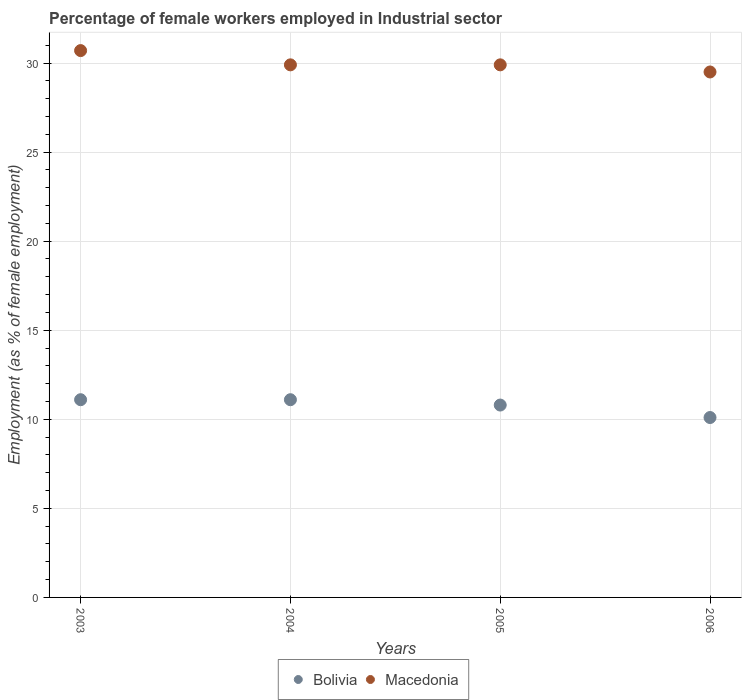What is the percentage of females employed in Industrial sector in Bolivia in 2005?
Provide a short and direct response. 10.8. Across all years, what is the maximum percentage of females employed in Industrial sector in Bolivia?
Your answer should be compact. 11.1. Across all years, what is the minimum percentage of females employed in Industrial sector in Macedonia?
Offer a terse response. 29.5. In which year was the percentage of females employed in Industrial sector in Macedonia minimum?
Offer a very short reply. 2006. What is the total percentage of females employed in Industrial sector in Bolivia in the graph?
Your response must be concise. 43.1. What is the difference between the percentage of females employed in Industrial sector in Bolivia in 2004 and that in 2005?
Give a very brief answer. 0.3. What is the difference between the percentage of females employed in Industrial sector in Macedonia in 2006 and the percentage of females employed in Industrial sector in Bolivia in 2004?
Provide a succinct answer. 18.4. What is the average percentage of females employed in Industrial sector in Macedonia per year?
Ensure brevity in your answer.  30. In the year 2004, what is the difference between the percentage of females employed in Industrial sector in Macedonia and percentage of females employed in Industrial sector in Bolivia?
Keep it short and to the point. 18.8. What is the ratio of the percentage of females employed in Industrial sector in Macedonia in 2005 to that in 2006?
Make the answer very short. 1.01. Is the percentage of females employed in Industrial sector in Macedonia in 2004 less than that in 2006?
Your answer should be very brief. No. What is the difference between the highest and the second highest percentage of females employed in Industrial sector in Macedonia?
Provide a succinct answer. 0.8. What is the difference between the highest and the lowest percentage of females employed in Industrial sector in Bolivia?
Your answer should be compact. 1. Is the sum of the percentage of females employed in Industrial sector in Bolivia in 2003 and 2006 greater than the maximum percentage of females employed in Industrial sector in Macedonia across all years?
Your response must be concise. No. Does the percentage of females employed in Industrial sector in Macedonia monotonically increase over the years?
Your response must be concise. No. What is the difference between two consecutive major ticks on the Y-axis?
Give a very brief answer. 5. Does the graph contain grids?
Give a very brief answer. Yes. How are the legend labels stacked?
Your answer should be compact. Horizontal. What is the title of the graph?
Your answer should be compact. Percentage of female workers employed in Industrial sector. Does "Australia" appear as one of the legend labels in the graph?
Give a very brief answer. No. What is the label or title of the Y-axis?
Offer a terse response. Employment (as % of female employment). What is the Employment (as % of female employment) in Bolivia in 2003?
Ensure brevity in your answer.  11.1. What is the Employment (as % of female employment) in Macedonia in 2003?
Provide a succinct answer. 30.7. What is the Employment (as % of female employment) in Bolivia in 2004?
Provide a succinct answer. 11.1. What is the Employment (as % of female employment) in Macedonia in 2004?
Make the answer very short. 29.9. What is the Employment (as % of female employment) of Bolivia in 2005?
Your answer should be very brief. 10.8. What is the Employment (as % of female employment) of Macedonia in 2005?
Make the answer very short. 29.9. What is the Employment (as % of female employment) of Bolivia in 2006?
Your answer should be very brief. 10.1. What is the Employment (as % of female employment) in Macedonia in 2006?
Your response must be concise. 29.5. Across all years, what is the maximum Employment (as % of female employment) of Bolivia?
Offer a terse response. 11.1. Across all years, what is the maximum Employment (as % of female employment) in Macedonia?
Your answer should be very brief. 30.7. Across all years, what is the minimum Employment (as % of female employment) in Bolivia?
Offer a terse response. 10.1. Across all years, what is the minimum Employment (as % of female employment) in Macedonia?
Your answer should be very brief. 29.5. What is the total Employment (as % of female employment) in Bolivia in the graph?
Provide a short and direct response. 43.1. What is the total Employment (as % of female employment) of Macedonia in the graph?
Your answer should be compact. 120. What is the difference between the Employment (as % of female employment) of Bolivia in 2003 and that in 2004?
Your response must be concise. 0. What is the difference between the Employment (as % of female employment) in Bolivia in 2003 and that in 2005?
Your response must be concise. 0.3. What is the difference between the Employment (as % of female employment) of Macedonia in 2003 and that in 2006?
Your answer should be very brief. 1.2. What is the difference between the Employment (as % of female employment) in Macedonia in 2004 and that in 2005?
Provide a short and direct response. 0. What is the difference between the Employment (as % of female employment) of Macedonia in 2004 and that in 2006?
Offer a very short reply. 0.4. What is the difference between the Employment (as % of female employment) in Macedonia in 2005 and that in 2006?
Your response must be concise. 0.4. What is the difference between the Employment (as % of female employment) of Bolivia in 2003 and the Employment (as % of female employment) of Macedonia in 2004?
Make the answer very short. -18.8. What is the difference between the Employment (as % of female employment) of Bolivia in 2003 and the Employment (as % of female employment) of Macedonia in 2005?
Your response must be concise. -18.8. What is the difference between the Employment (as % of female employment) in Bolivia in 2003 and the Employment (as % of female employment) in Macedonia in 2006?
Your answer should be very brief. -18.4. What is the difference between the Employment (as % of female employment) in Bolivia in 2004 and the Employment (as % of female employment) in Macedonia in 2005?
Your response must be concise. -18.8. What is the difference between the Employment (as % of female employment) of Bolivia in 2004 and the Employment (as % of female employment) of Macedonia in 2006?
Your answer should be very brief. -18.4. What is the difference between the Employment (as % of female employment) in Bolivia in 2005 and the Employment (as % of female employment) in Macedonia in 2006?
Offer a very short reply. -18.7. What is the average Employment (as % of female employment) in Bolivia per year?
Provide a short and direct response. 10.78. What is the average Employment (as % of female employment) of Macedonia per year?
Give a very brief answer. 30. In the year 2003, what is the difference between the Employment (as % of female employment) in Bolivia and Employment (as % of female employment) in Macedonia?
Make the answer very short. -19.6. In the year 2004, what is the difference between the Employment (as % of female employment) of Bolivia and Employment (as % of female employment) of Macedonia?
Provide a succinct answer. -18.8. In the year 2005, what is the difference between the Employment (as % of female employment) of Bolivia and Employment (as % of female employment) of Macedonia?
Offer a terse response. -19.1. In the year 2006, what is the difference between the Employment (as % of female employment) in Bolivia and Employment (as % of female employment) in Macedonia?
Ensure brevity in your answer.  -19.4. What is the ratio of the Employment (as % of female employment) of Bolivia in 2003 to that in 2004?
Offer a terse response. 1. What is the ratio of the Employment (as % of female employment) of Macedonia in 2003 to that in 2004?
Offer a very short reply. 1.03. What is the ratio of the Employment (as % of female employment) of Bolivia in 2003 to that in 2005?
Your answer should be very brief. 1.03. What is the ratio of the Employment (as % of female employment) in Macedonia in 2003 to that in 2005?
Keep it short and to the point. 1.03. What is the ratio of the Employment (as % of female employment) in Bolivia in 2003 to that in 2006?
Make the answer very short. 1.1. What is the ratio of the Employment (as % of female employment) of Macedonia in 2003 to that in 2006?
Offer a very short reply. 1.04. What is the ratio of the Employment (as % of female employment) of Bolivia in 2004 to that in 2005?
Your answer should be compact. 1.03. What is the ratio of the Employment (as % of female employment) of Bolivia in 2004 to that in 2006?
Your answer should be compact. 1.1. What is the ratio of the Employment (as % of female employment) of Macedonia in 2004 to that in 2006?
Give a very brief answer. 1.01. What is the ratio of the Employment (as % of female employment) in Bolivia in 2005 to that in 2006?
Provide a succinct answer. 1.07. What is the ratio of the Employment (as % of female employment) in Macedonia in 2005 to that in 2006?
Ensure brevity in your answer.  1.01. What is the difference between the highest and the second highest Employment (as % of female employment) in Macedonia?
Provide a succinct answer. 0.8. What is the difference between the highest and the lowest Employment (as % of female employment) of Bolivia?
Offer a terse response. 1. What is the difference between the highest and the lowest Employment (as % of female employment) in Macedonia?
Keep it short and to the point. 1.2. 